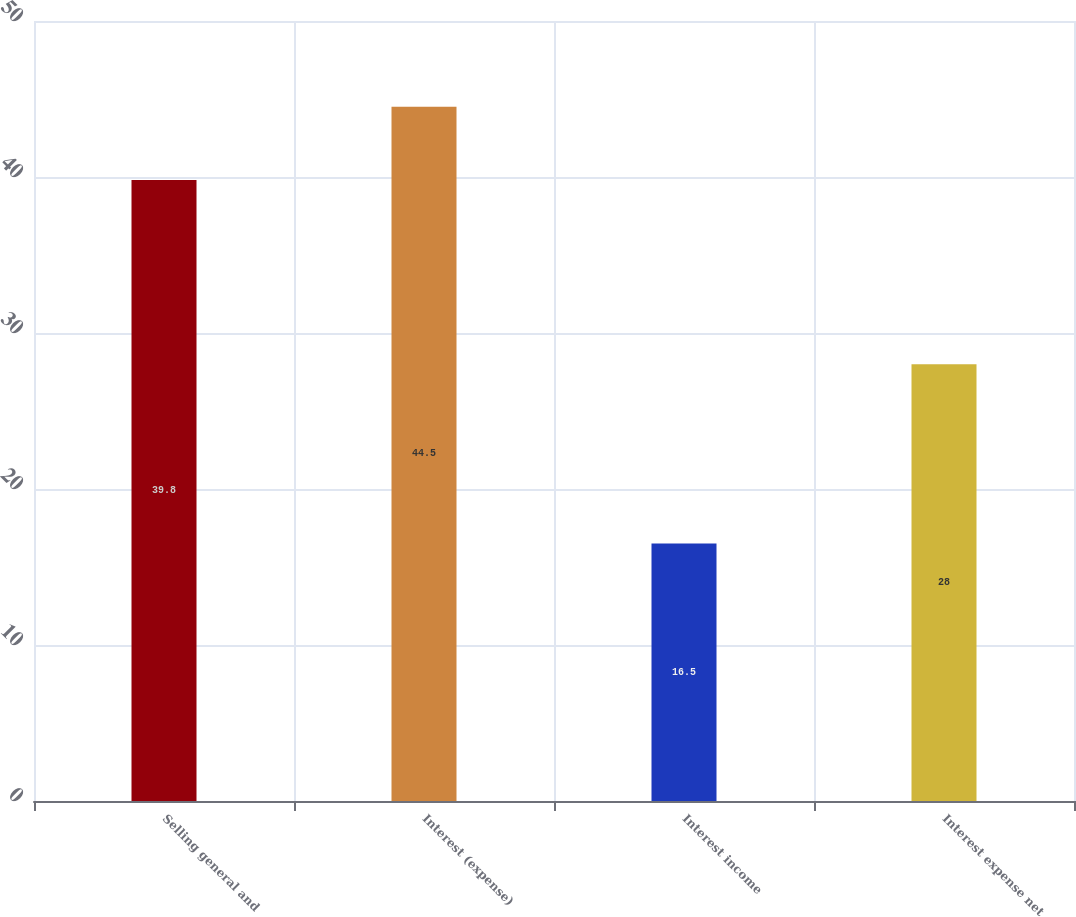<chart> <loc_0><loc_0><loc_500><loc_500><bar_chart><fcel>Selling general and<fcel>Interest (expense)<fcel>Interest income<fcel>Interest expense net<nl><fcel>39.8<fcel>44.5<fcel>16.5<fcel>28<nl></chart> 